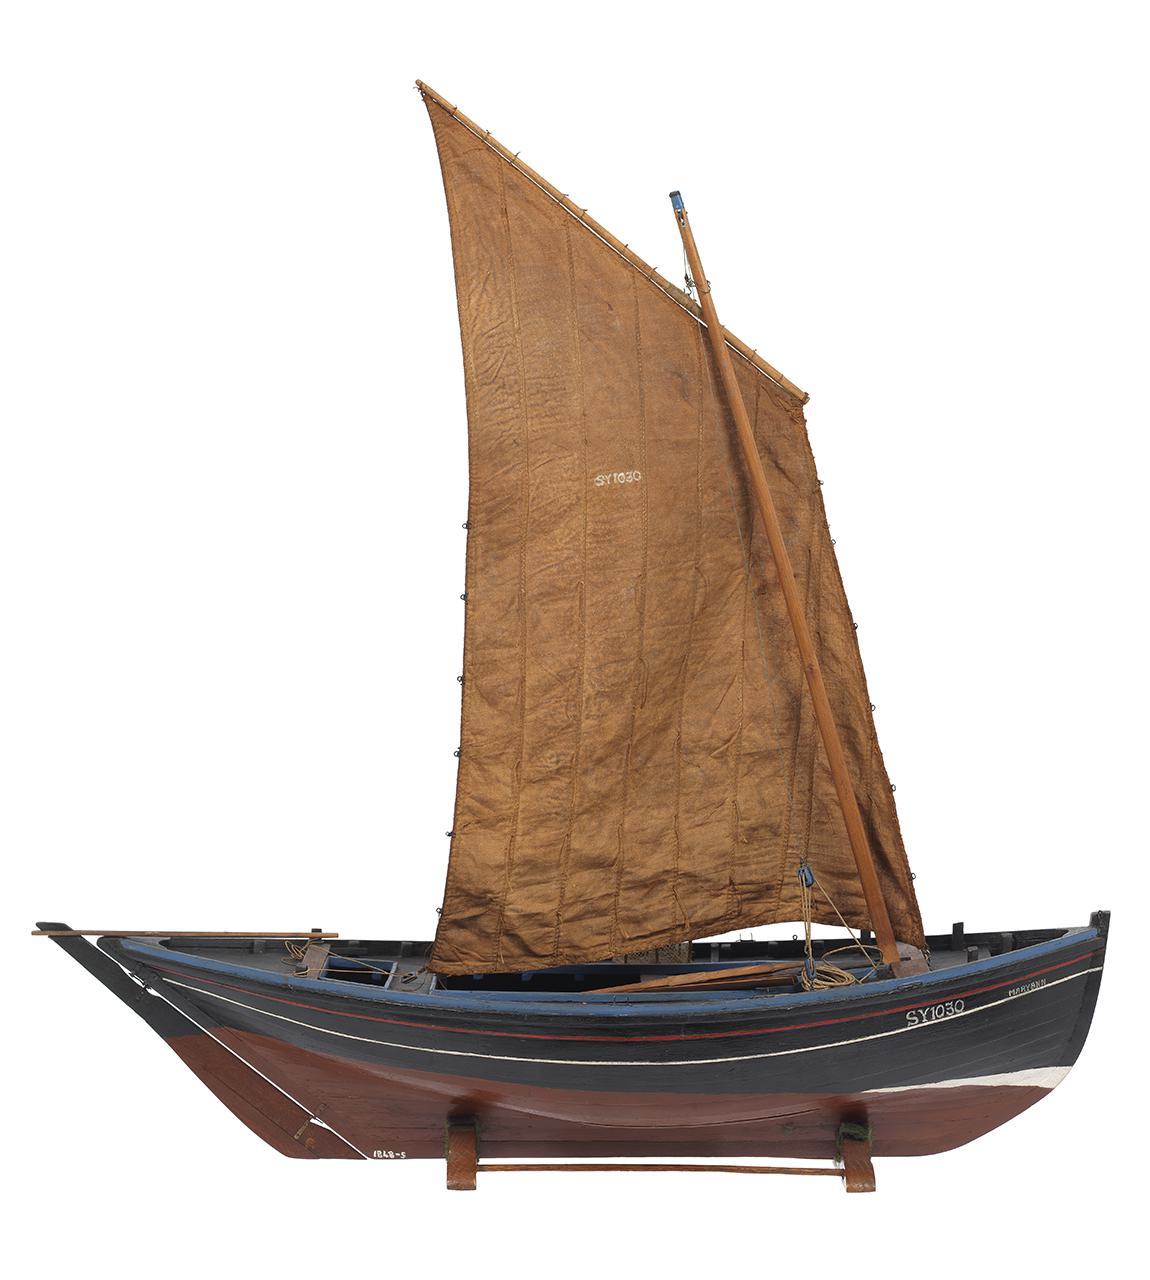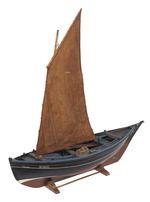The first image is the image on the left, the second image is the image on the right. For the images displayed, is the sentence "Right image features a boat with only brown sails." factually correct? Answer yes or no. Yes. The first image is the image on the left, the second image is the image on the right. Given the left and right images, does the statement "Two sailboat models are sitting on matching stands." hold true? Answer yes or no. Yes. 